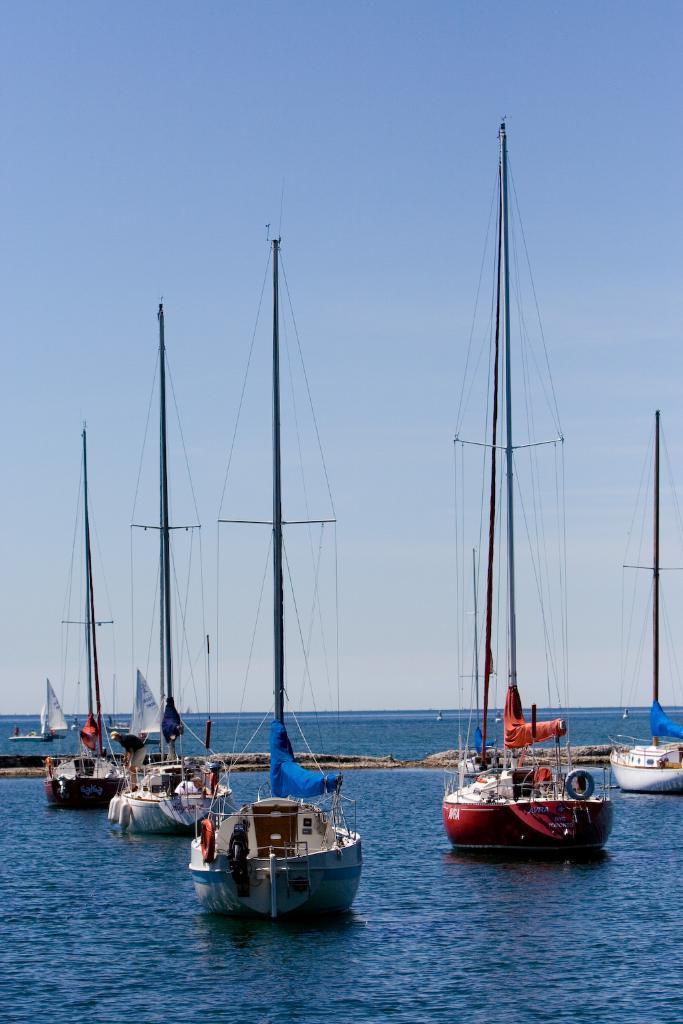Can you describe this image briefly? In this image we can see so many ships are on the surface of water. The sky is in blue color. 